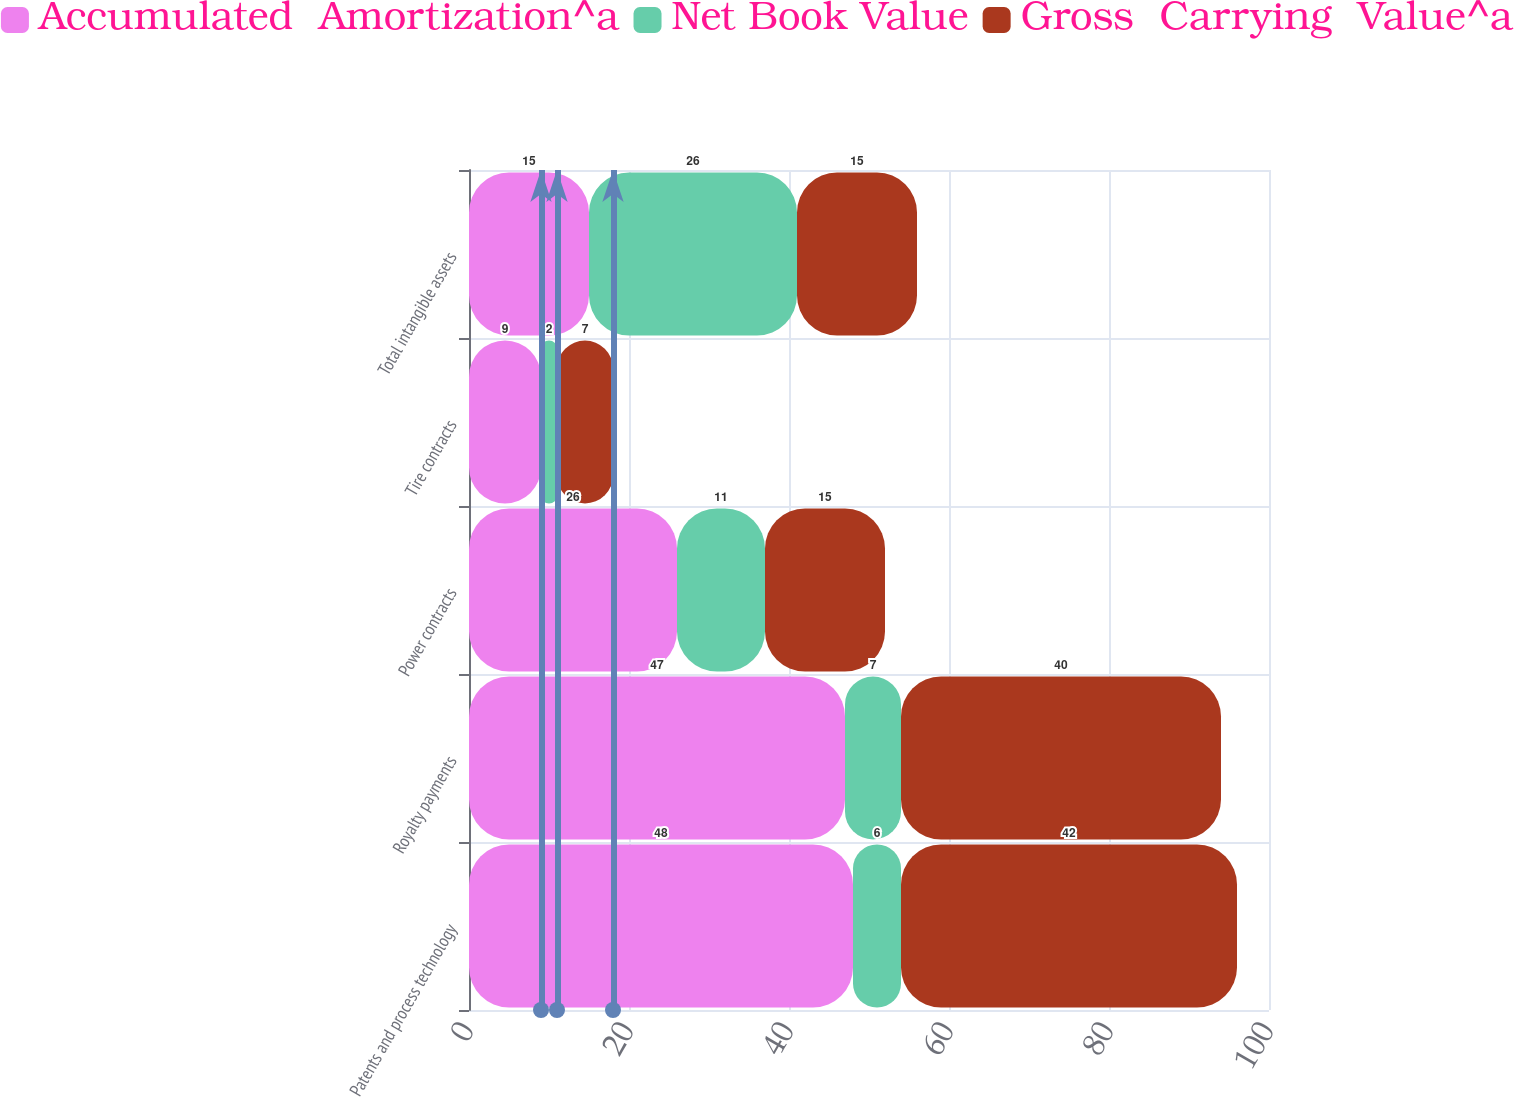<chart> <loc_0><loc_0><loc_500><loc_500><stacked_bar_chart><ecel><fcel>Patents and process technology<fcel>Royalty payments<fcel>Power contracts<fcel>Tire contracts<fcel>Total intangible assets<nl><fcel>Accumulated  Amortization^a<fcel>48<fcel>47<fcel>26<fcel>9<fcel>15<nl><fcel>Net Book Value<fcel>6<fcel>7<fcel>11<fcel>2<fcel>26<nl><fcel>Gross  Carrying  Value^a<fcel>42<fcel>40<fcel>15<fcel>7<fcel>15<nl></chart> 